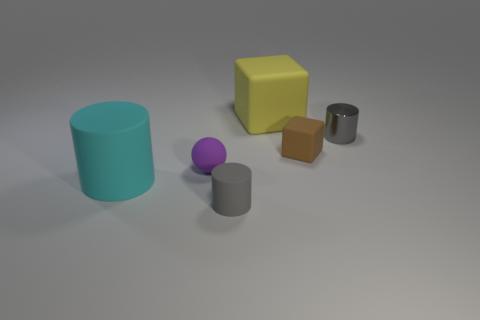Add 2 small yellow matte blocks. How many objects exist? 8 Subtract all balls. How many objects are left? 5 Subtract 0 red blocks. How many objects are left? 6 Subtract all large yellow matte objects. Subtract all yellow rubber objects. How many objects are left? 4 Add 1 small brown rubber cubes. How many small brown rubber cubes are left? 2 Add 5 tiny gray shiny things. How many tiny gray shiny things exist? 6 